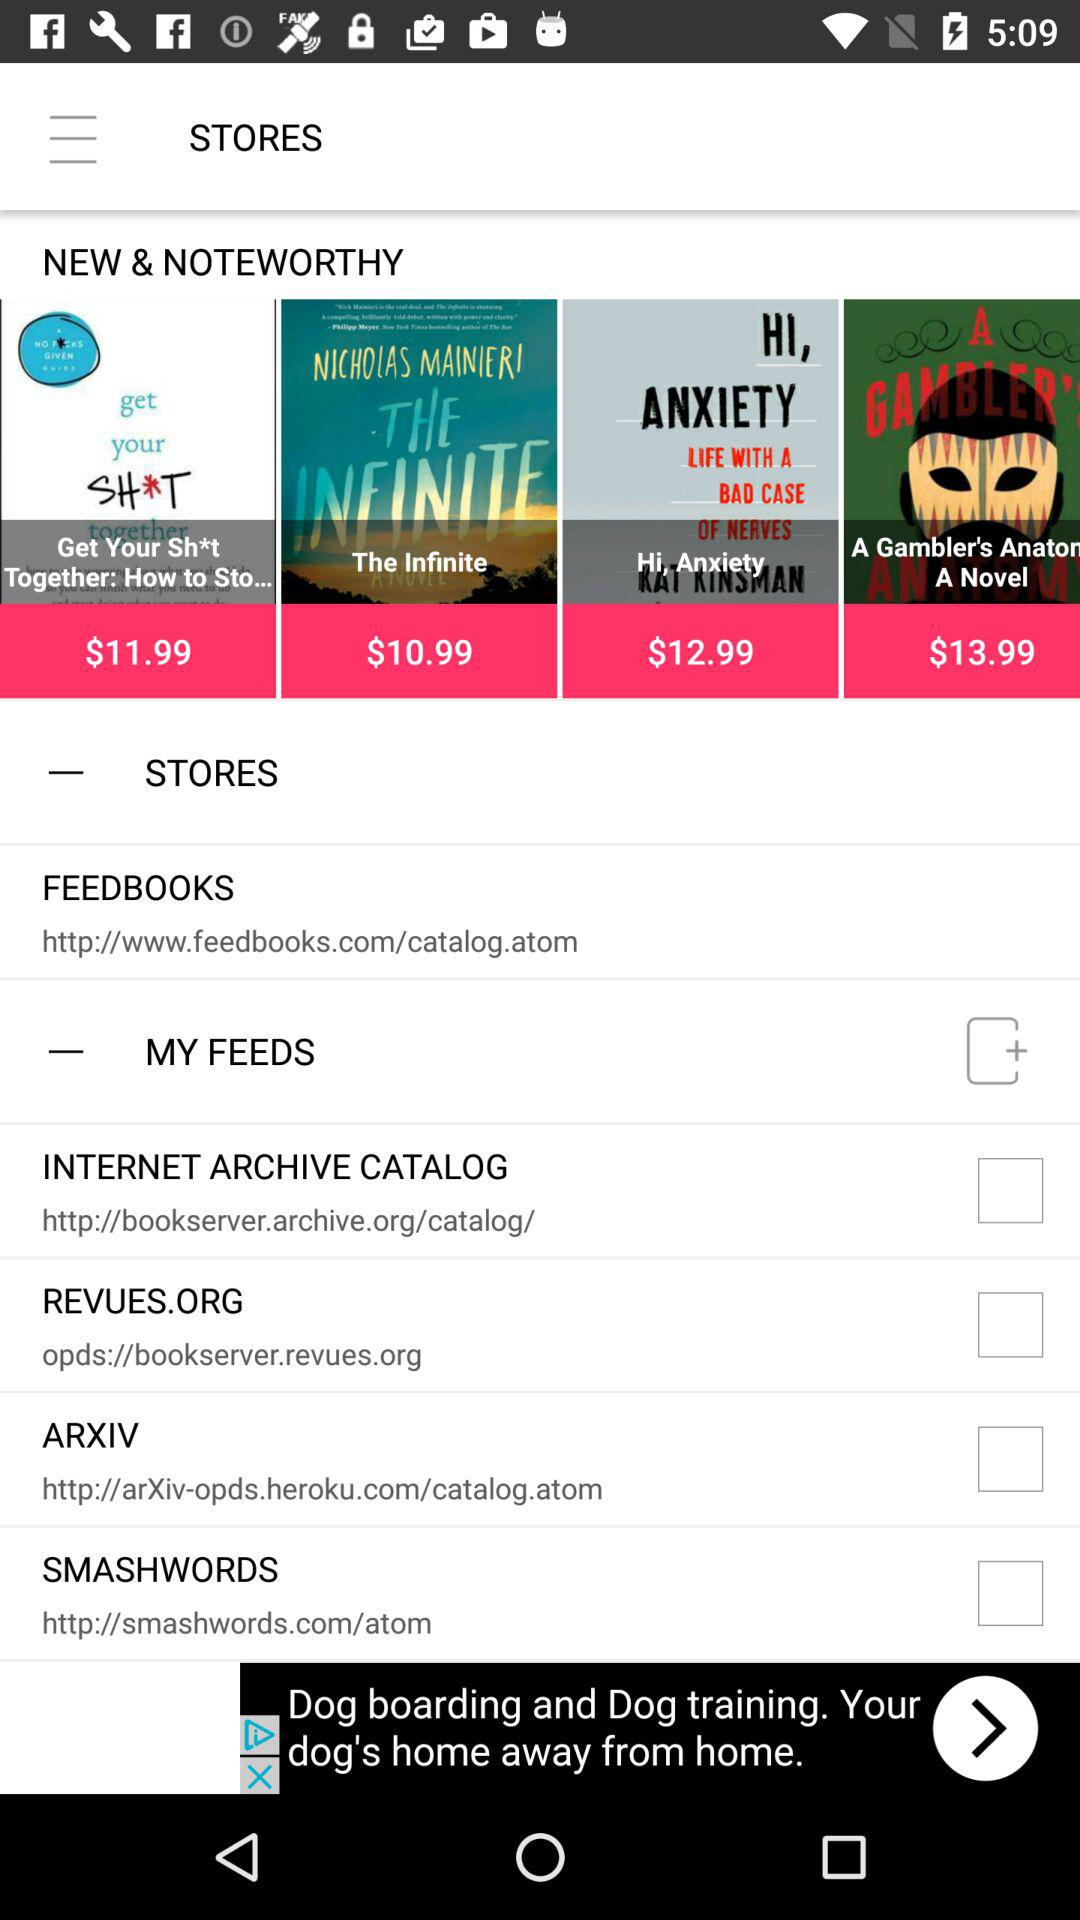What is the cost of the Infinite? The cost of the Infinite is $10.99. 